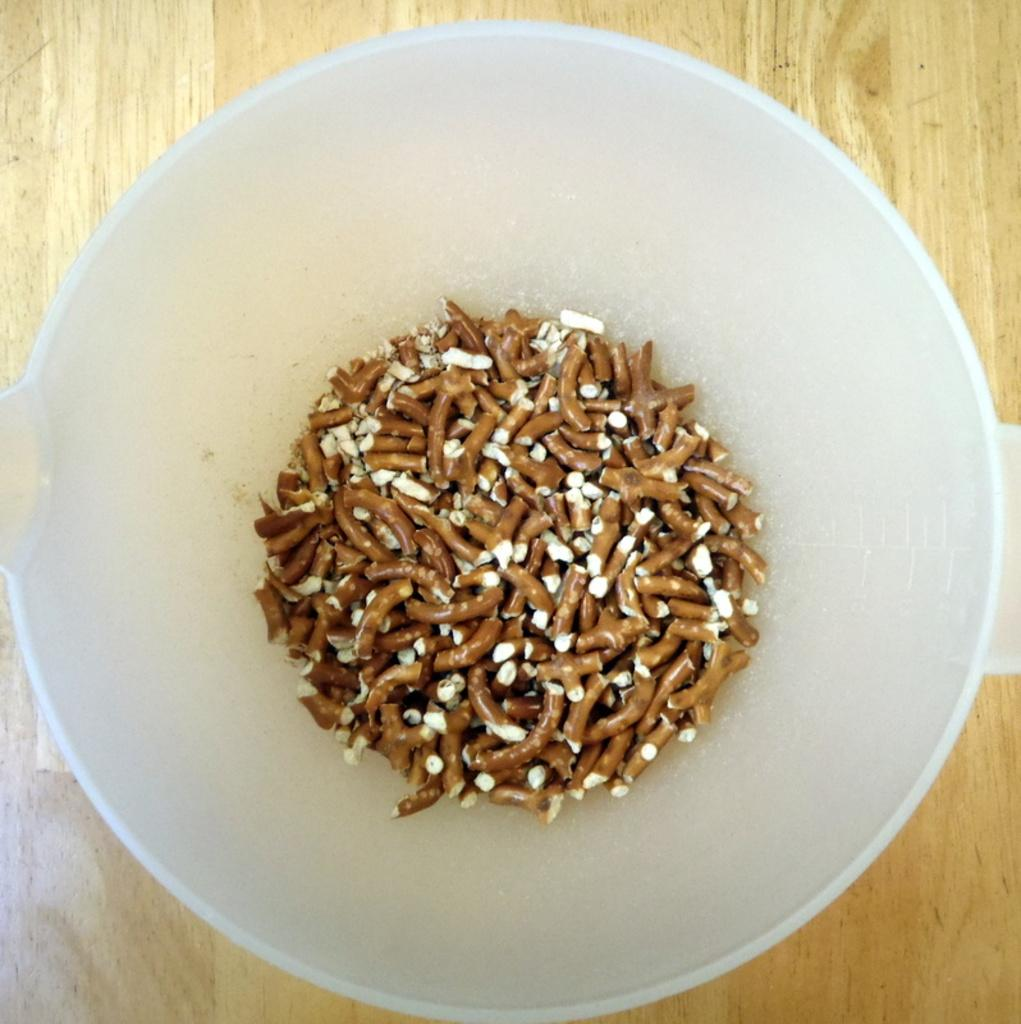What is located in the center of the image? There is a bowl in the center of the image. What is inside the bowl? There are food items in the bowl. What can be seen in the background of the image? There is a wooden board in the background of the image. What type of whip is being used to control the food items in the image? There is no whip present in the image, and the food items are not being controlled by any external force. 